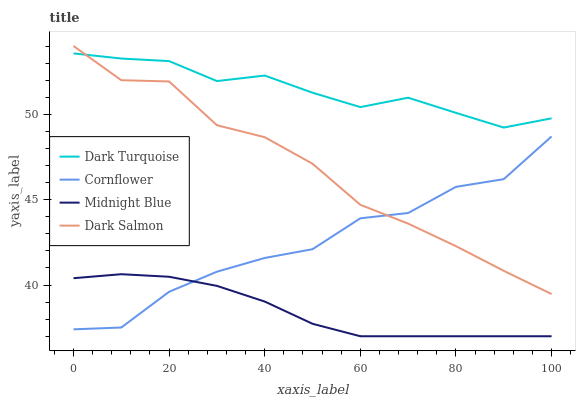Does Midnight Blue have the minimum area under the curve?
Answer yes or no. Yes. Does Dark Turquoise have the maximum area under the curve?
Answer yes or no. Yes. Does Dark Salmon have the minimum area under the curve?
Answer yes or no. No. Does Dark Salmon have the maximum area under the curve?
Answer yes or no. No. Is Midnight Blue the smoothest?
Answer yes or no. Yes. Is Cornflower the roughest?
Answer yes or no. Yes. Is Dark Salmon the smoothest?
Answer yes or no. No. Is Dark Salmon the roughest?
Answer yes or no. No. Does Midnight Blue have the lowest value?
Answer yes or no. Yes. Does Dark Salmon have the lowest value?
Answer yes or no. No. Does Dark Salmon have the highest value?
Answer yes or no. Yes. Does Midnight Blue have the highest value?
Answer yes or no. No. Is Midnight Blue less than Dark Salmon?
Answer yes or no. Yes. Is Dark Turquoise greater than Midnight Blue?
Answer yes or no. Yes. Does Cornflower intersect Dark Salmon?
Answer yes or no. Yes. Is Cornflower less than Dark Salmon?
Answer yes or no. No. Is Cornflower greater than Dark Salmon?
Answer yes or no. No. Does Midnight Blue intersect Dark Salmon?
Answer yes or no. No. 